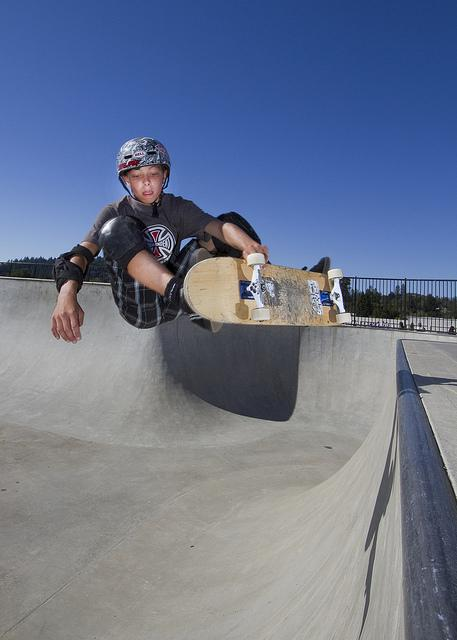Why is his head covered? Please explain your reasoning. protection. Skateboarding is done on concrete. concrete is hard. a head is not hard. the helmet protects the head if it comes in contact with the concrete. 